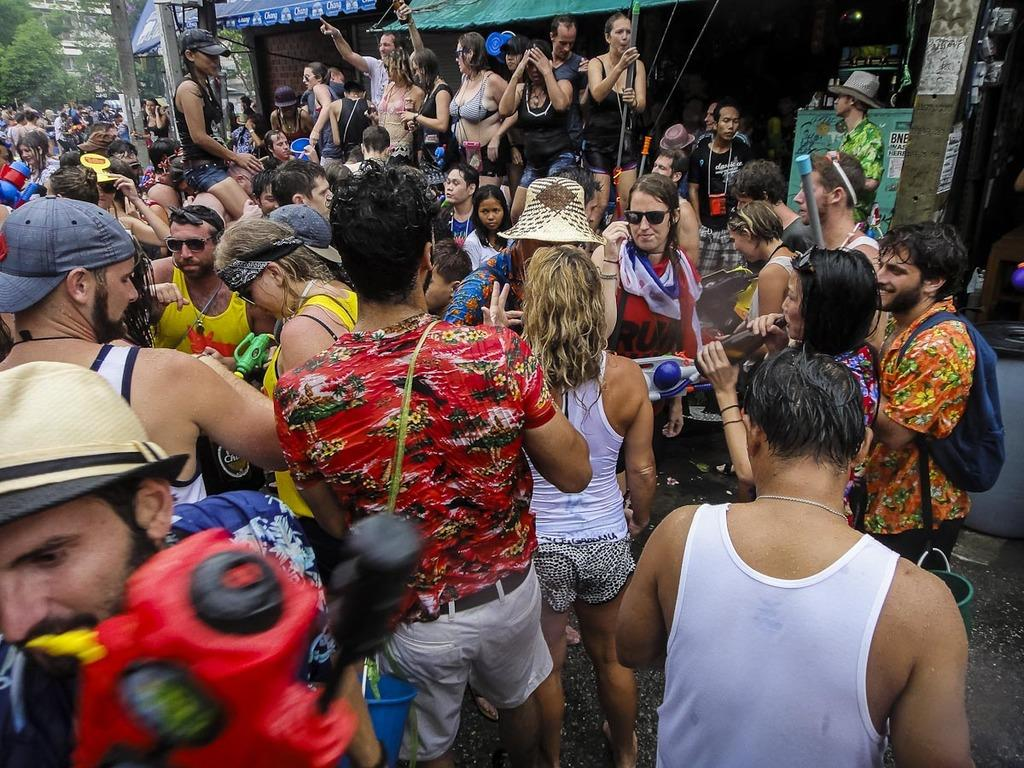How many people are in the group in the image? There is a group of people in the image, but the exact number cannot be determined from the provided facts. What are some people in the group doing in the image? Some people in the group are holding objects in their hands. What can be seen in the background of the image? There are trees, a building, and other objects visible in the background of the image. What type of wine is being served at the dinner in the image? There is no dinner or wine present in the image; it features a group of people and objects in their hands. 